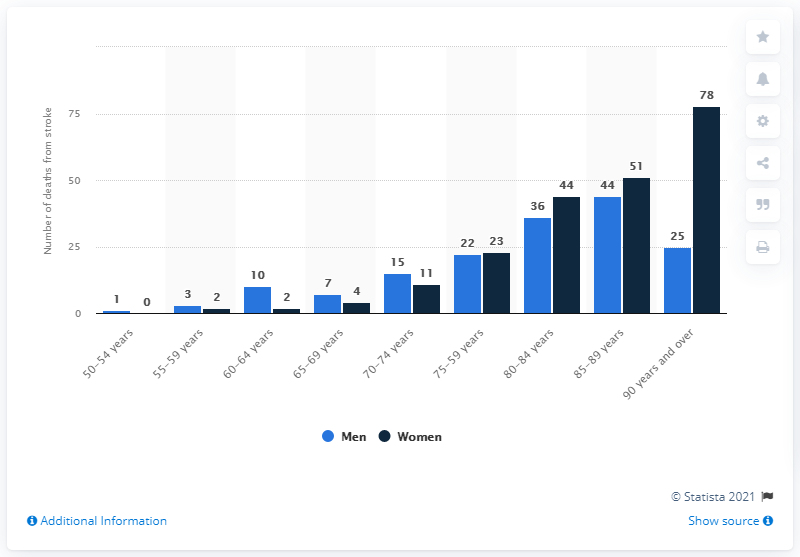Identify some key points in this picture. In 2019, 78 women over the age of 90 in Northern Ireland died as a result of stroke. 